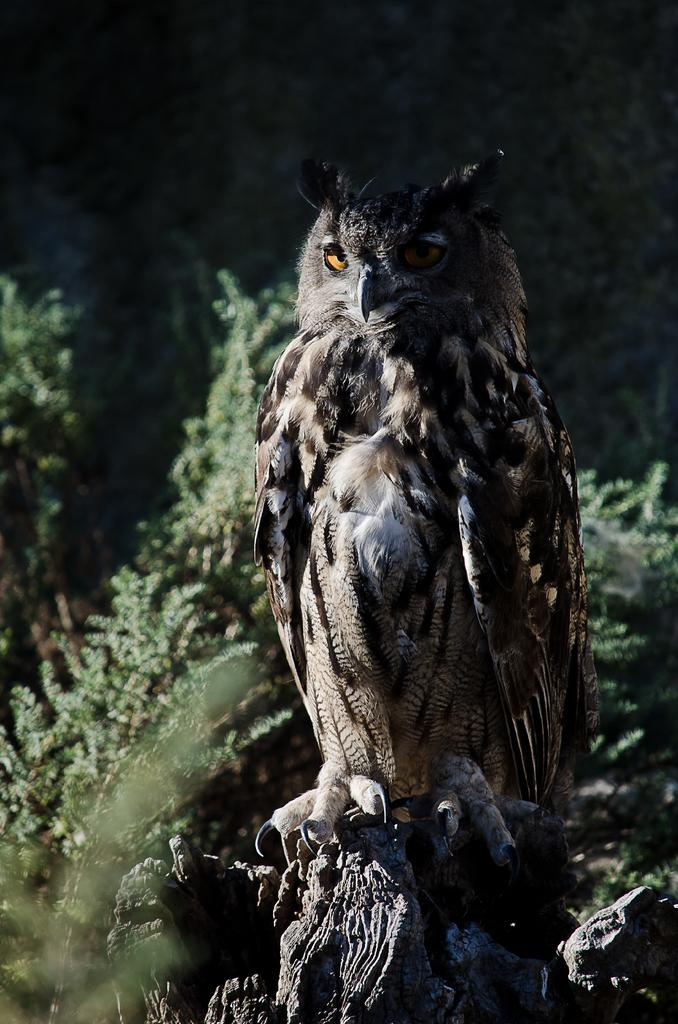What animal is the main subject of the image? There is an owl in the image. Where is the owl located in the image? The owl is in the middle of the image. What can be seen in the background of the image? There are plants in the background of the image. What type of toothbrush is the owl using in the image? There is no toothbrush present in the image; it features an owl and plants in the background. What kind of beast is depicted alongside the owl in the image? There is no beast depicted alongside the owl in the image; it only features the owl and plants in the background. 